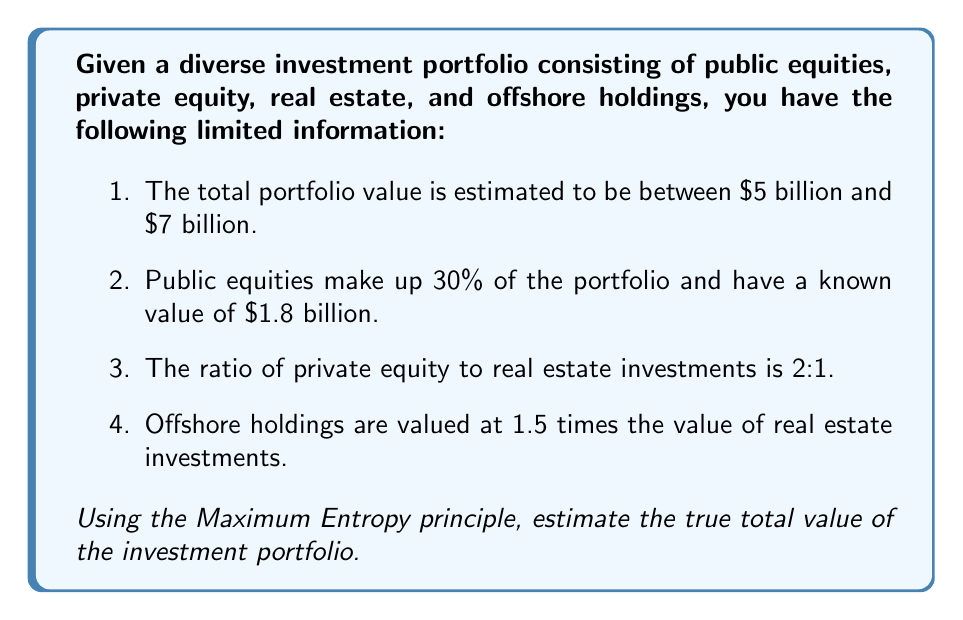Can you answer this question? To solve this inverse problem using the Maximum Entropy principle, we'll follow these steps:

1) Let's define our variables:
   $x_1$ = public equities
   $x_2$ = private equity
   $x_3$ = real estate
   $x_4$ = offshore holdings

2) We know that $x_1 = 1.8$ billion.

3) We can express the other variables in terms of $x_3$:
   $x_2 = 2x_3$ (given ratio of private equity to real estate)
   $x_4 = 1.5x_3$ (given ratio of offshore holdings to real estate)

4) The total portfolio value $V$ is:
   $V = x_1 + x_2 + x_3 + x_4 = 1.8 + 2x_3 + x_3 + 1.5x_3 = 1.8 + 4.5x_3$

5) We're told that $5 \leq V \leq 7$. Substituting:
   $5 \leq 1.8 + 4.5x_3 \leq 7$

6) Solving these inequalities:
   $0.71 \leq x_3 \leq 1.16$

7) The Maximum Entropy principle suggests we should choose the midpoint of this range for $x_3$:
   $x_3 = (0.71 + 1.16) / 2 = 0.935$

8) Now we can calculate the other values:
   $x_2 = 2(0.935) = 1.87$
   $x_4 = 1.5(0.935) = 1.4025$

9) The total estimated value is:
   $V = 1.8 + 1.87 + 0.935 + 1.4025 = 6.0075$ billion
Answer: $6.0075 billion 